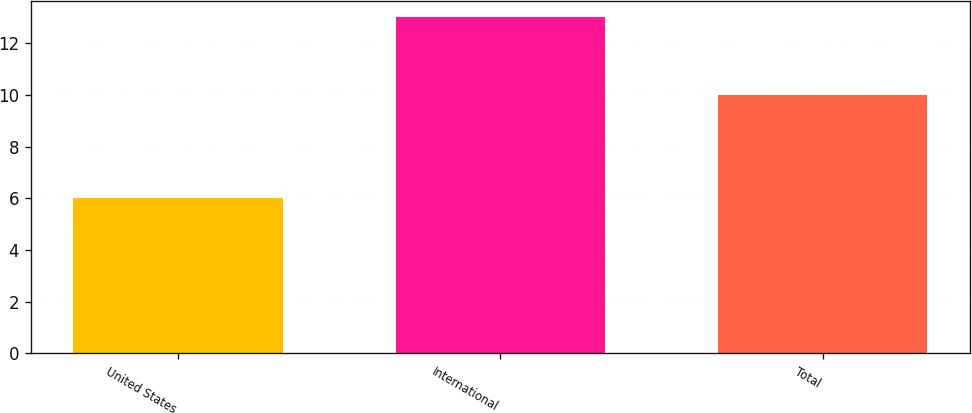Convert chart to OTSL. <chart><loc_0><loc_0><loc_500><loc_500><bar_chart><fcel>United States<fcel>International<fcel>Total<nl><fcel>6<fcel>13<fcel>10<nl></chart> 